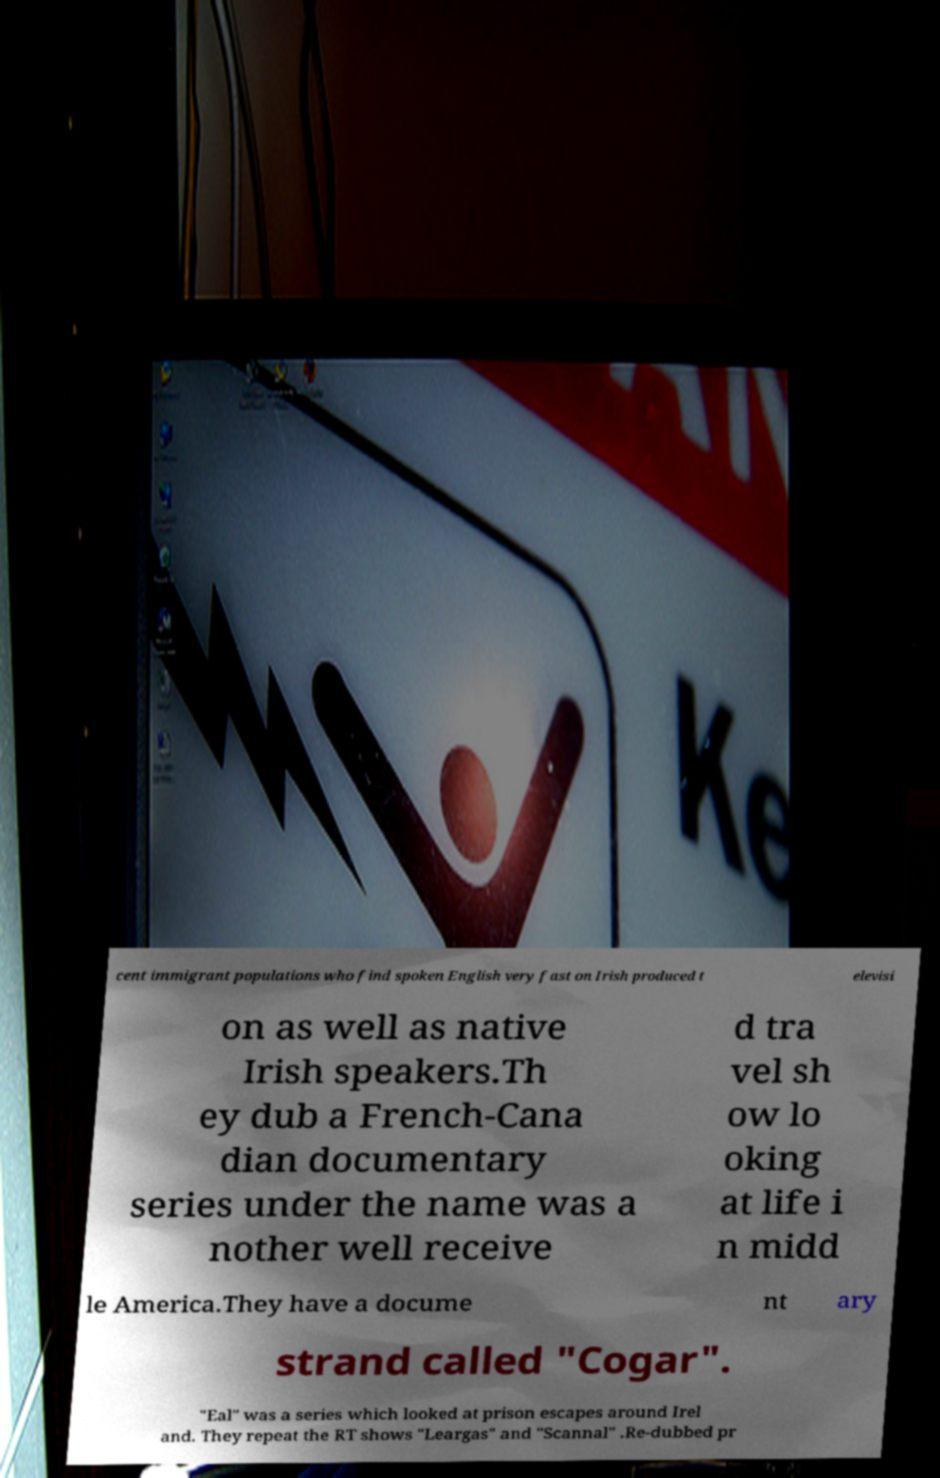For documentation purposes, I need the text within this image transcribed. Could you provide that? cent immigrant populations who find spoken English very fast on Irish produced t elevisi on as well as native Irish speakers.Th ey dub a French-Cana dian documentary series under the name was a nother well receive d tra vel sh ow lo oking at life i n midd le America.They have a docume nt ary strand called "Cogar". "Eal" was a series which looked at prison escapes around Irel and. They repeat the RT shows "Leargas" and "Scannal" .Re-dubbed pr 